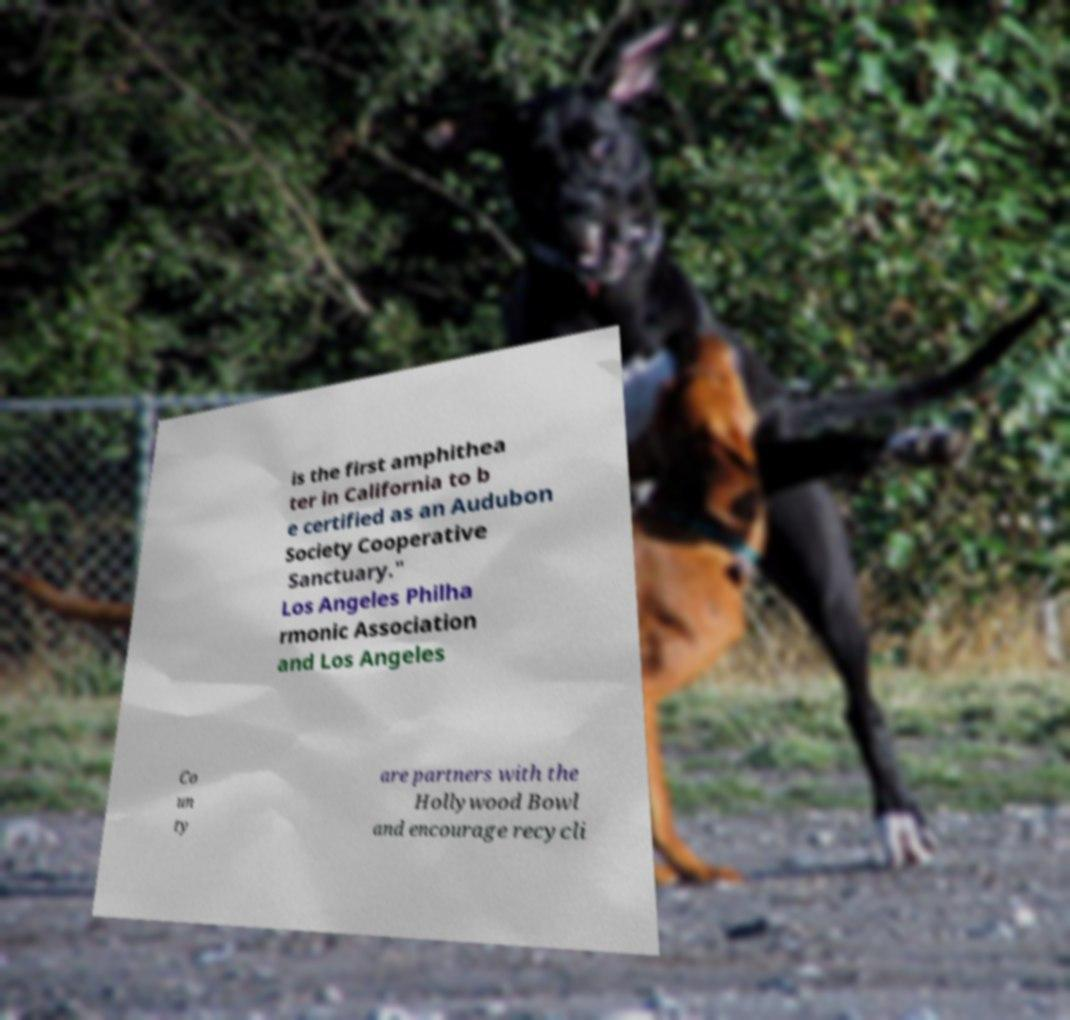Can you read and provide the text displayed in the image?This photo seems to have some interesting text. Can you extract and type it out for me? is the first amphithea ter in California to b e certified as an Audubon Society Cooperative Sanctuary." Los Angeles Philha rmonic Association and Los Angeles Co un ty are partners with the Hollywood Bowl and encourage recycli 